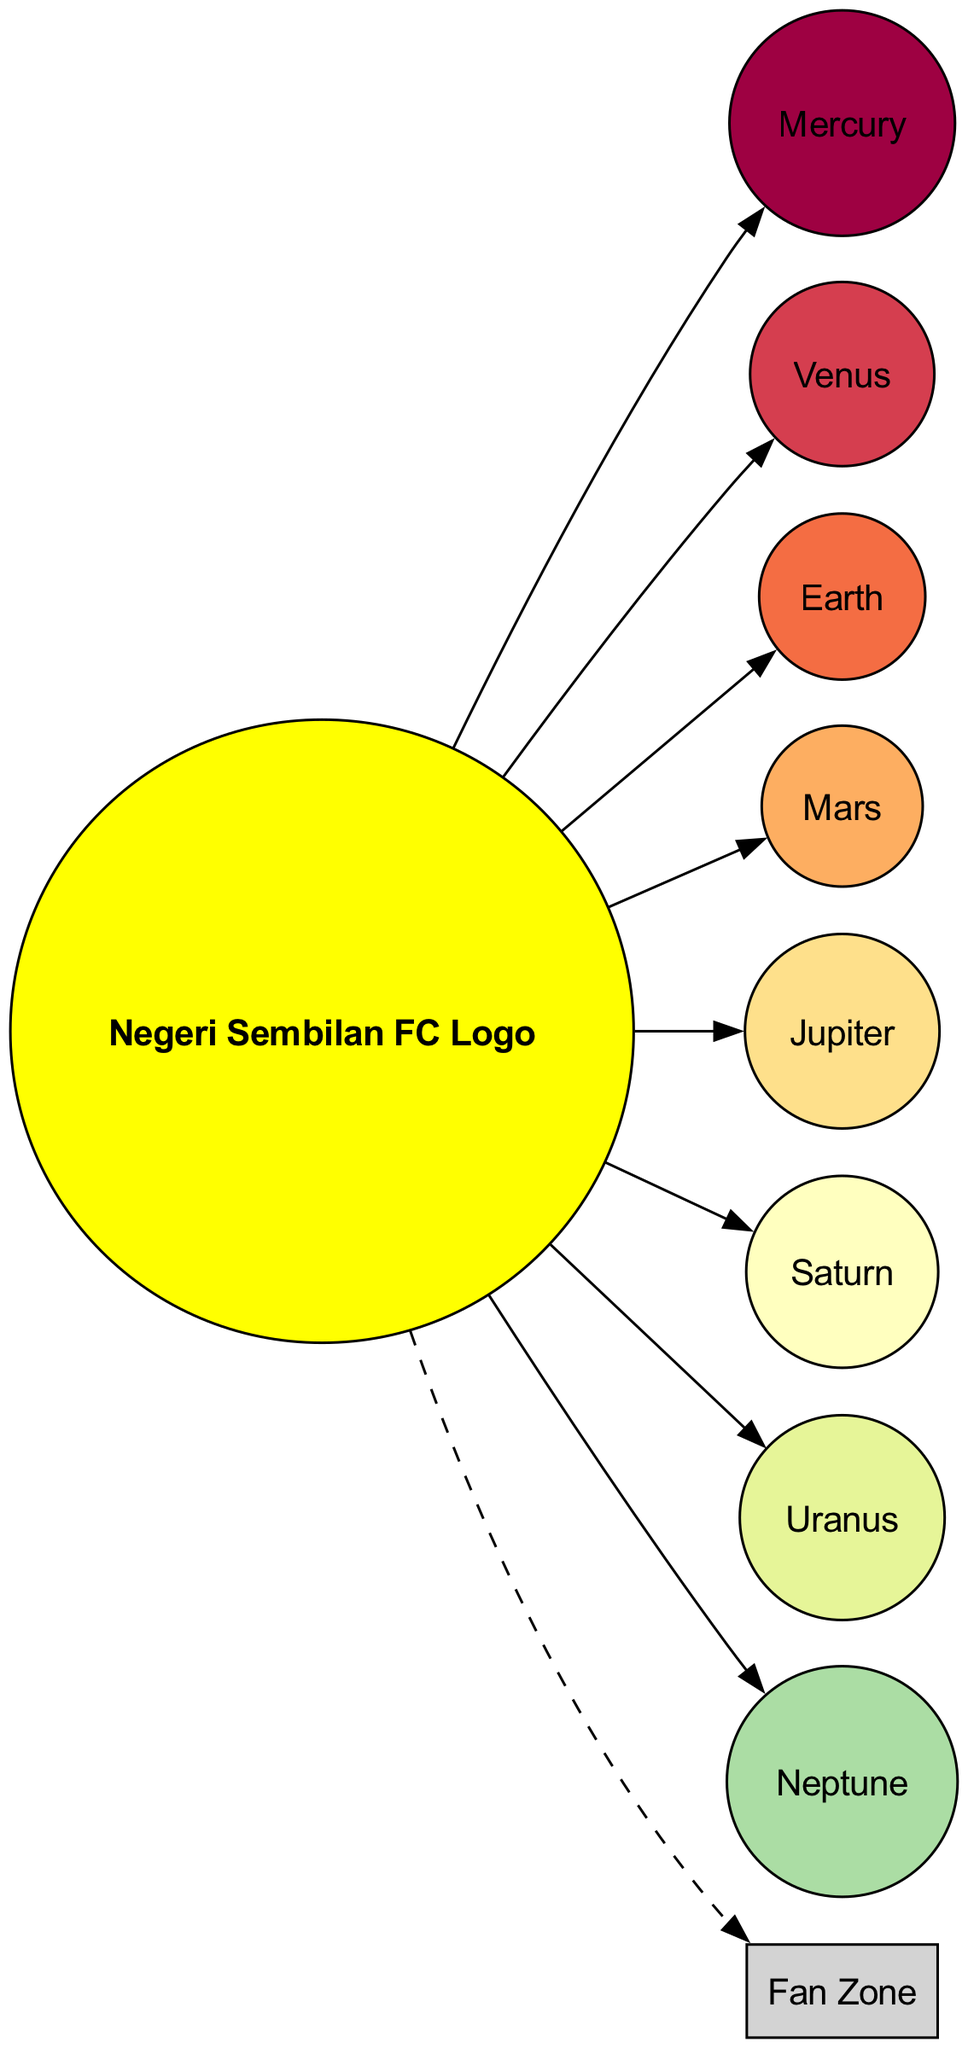What is at the center of the solar system model? The center of the solar system model is represented by the Negeri Sembilan FC Logo. This is clearly indicated as the center node in the diagram, which shows the team logo.
Answer: Negeri Sembilan FC Logo How many planets are shown in the diagram? The diagram lists a total of eight planets, each represented as a football with unique features. The number is counted by identifying each planet node in the diagram.
Answer: 8 Which planet has a description related to the away kit? The planet Uranus is described as having a blue ball with the away kit pattern. We can derive this by examining the descriptions given for each planet.
Answer: Uranus What does the asteroid belt represent? The asteroid belt is labeled "Fan Zone," and it represents miniature footballs correlating to the supporters. This is stated in the description provided for the asteroid belt node.
Answer: Fan Zone What color is the football representing Mars? The football representing Mars is red. This information is directly found in the description of Mars, which states it is a red football.
Answer: Red Which planet is represented by the official match ball? Earth is referred to as the official match ball in the diagram. We deduce this by directly linking the planet name with its corresponding description, which explicitly states this.
Answer: Earth How is Saturn depicted in the diagram? Saturn is depicted as a ball with rings made of supporter scarves. This can be inferred from the description that outlines what visual features distinguish Saturn from the other planets.
Answer: Ball with rings of supporter scarves What is the color of the football representing Neptune? The football representing Neptune is dark blue. This color is highlighted in the specific description provided for Neptune in the diagram.
Answer: Dark blue 